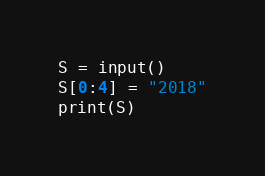Convert code to text. <code><loc_0><loc_0><loc_500><loc_500><_Python_>S = input()
S[0:4] = "2018"
print(S)</code> 